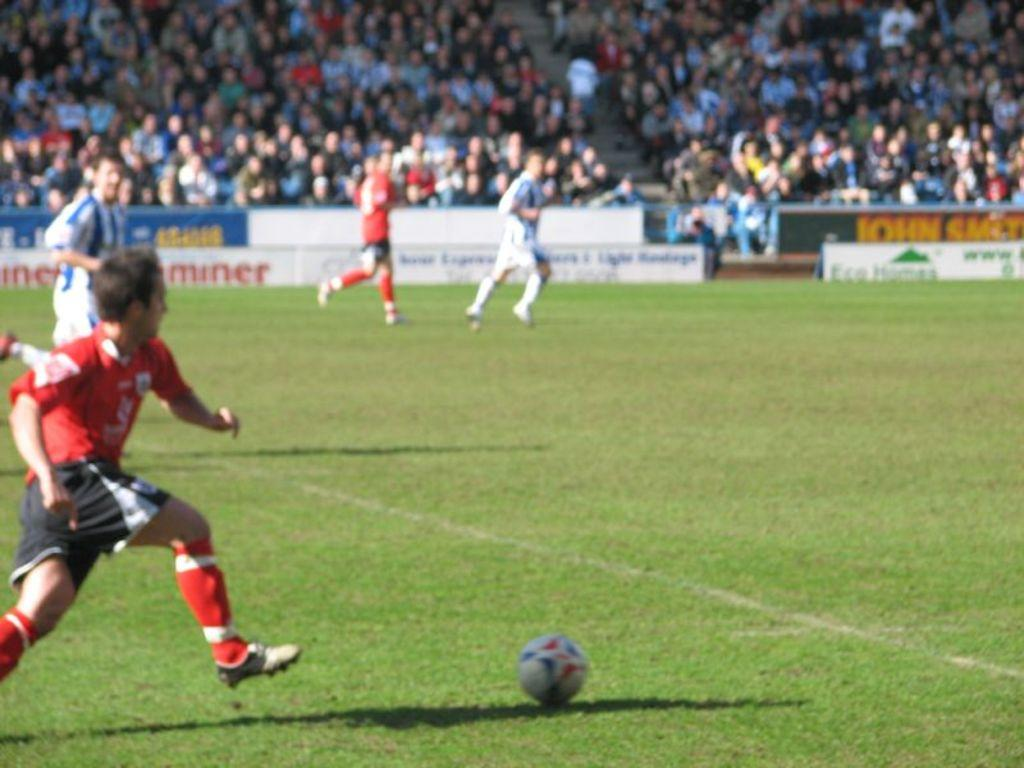<image>
Give a short and clear explanation of the subsequent image. two soccer teams running down the field, with a sponsor "miner" on the ads behind them 